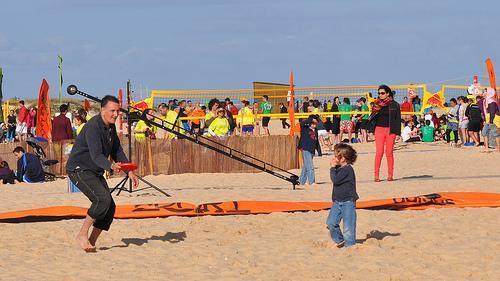How many orangish-red banners are to the left of the man holding the red frisbee?
Give a very brief answer. 1. 